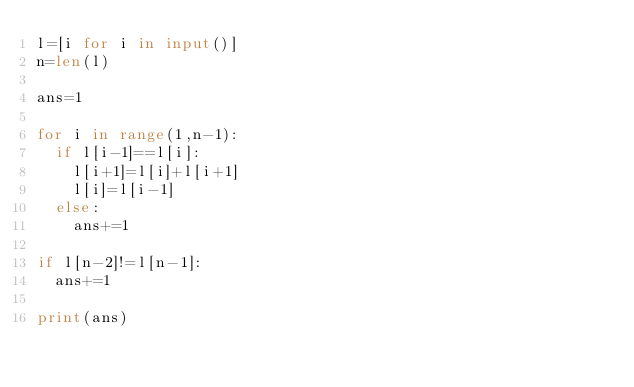Convert code to text. <code><loc_0><loc_0><loc_500><loc_500><_Python_>l=[i for i in input()]
n=len(l)

ans=1

for i in range(1,n-1):
  if l[i-1]==l[i]:
    l[i+1]=l[i]+l[i+1]
    l[i]=l[i-1]
  else:
    ans+=1

if l[n-2]!=l[n-1]:
  ans+=1
    
print(ans)</code> 